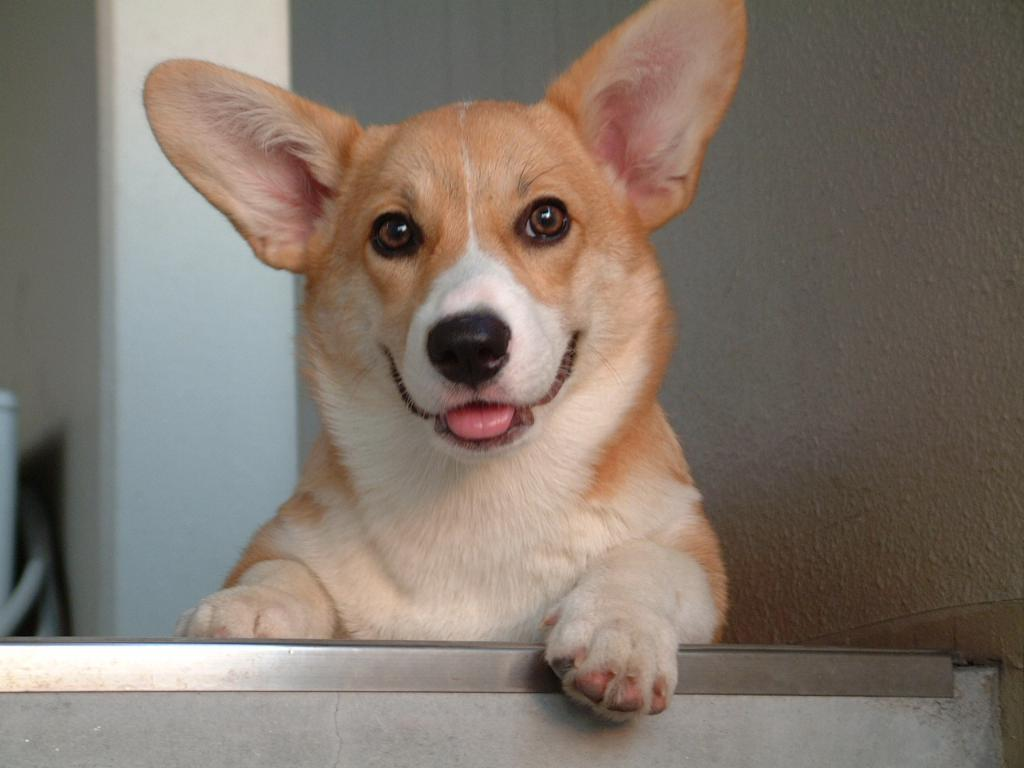What type of animal is present in the image? There is a dog in the image. Can you describe the color pattern of the dog? The dog is colored brown and white. What can be seen in the background of the image? There is a wall in the background of the image. Where is the shelf located in the image? There is no shelf present in the image. What type of throne does the dog sit on in the image? There is no throne present in the image; the dog is not sitting on any furniture. 